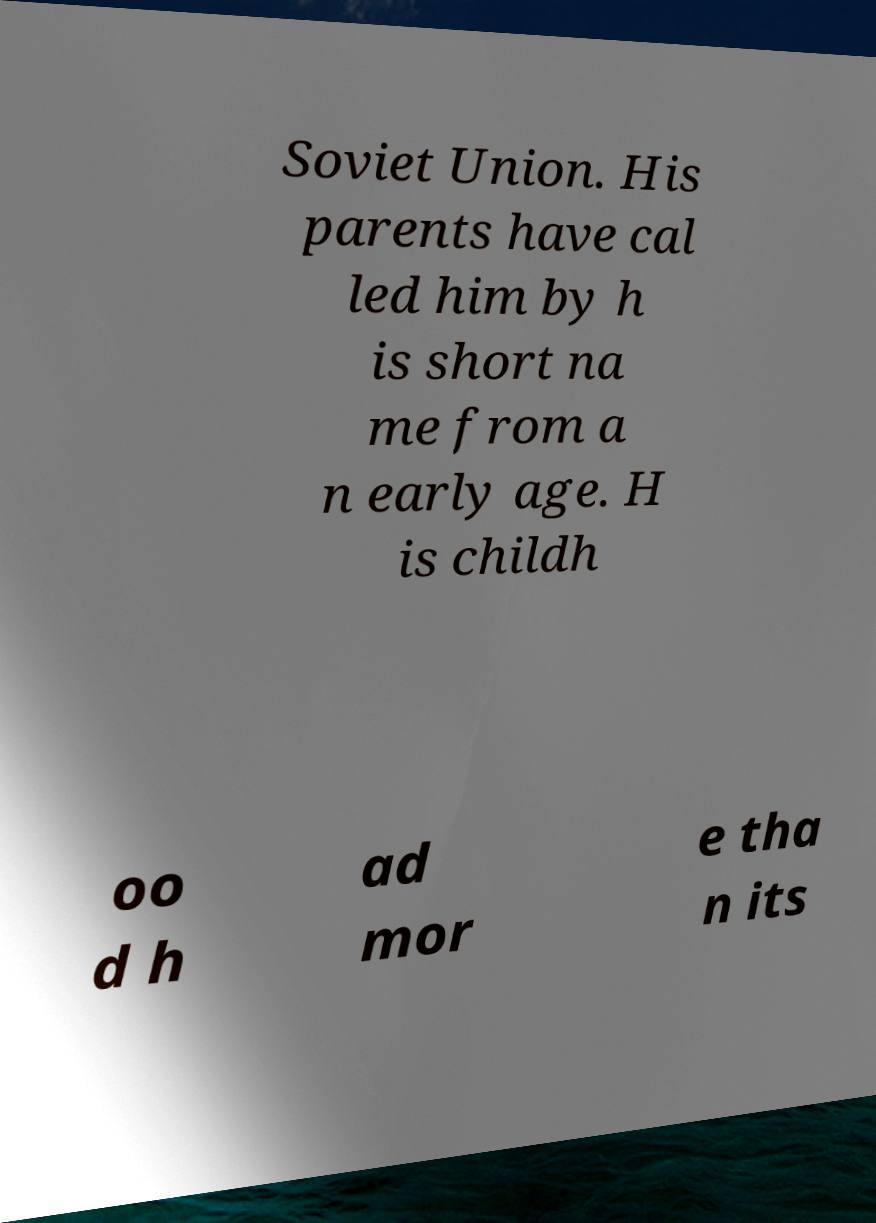For documentation purposes, I need the text within this image transcribed. Could you provide that? Soviet Union. His parents have cal led him by h is short na me from a n early age. H is childh oo d h ad mor e tha n its 